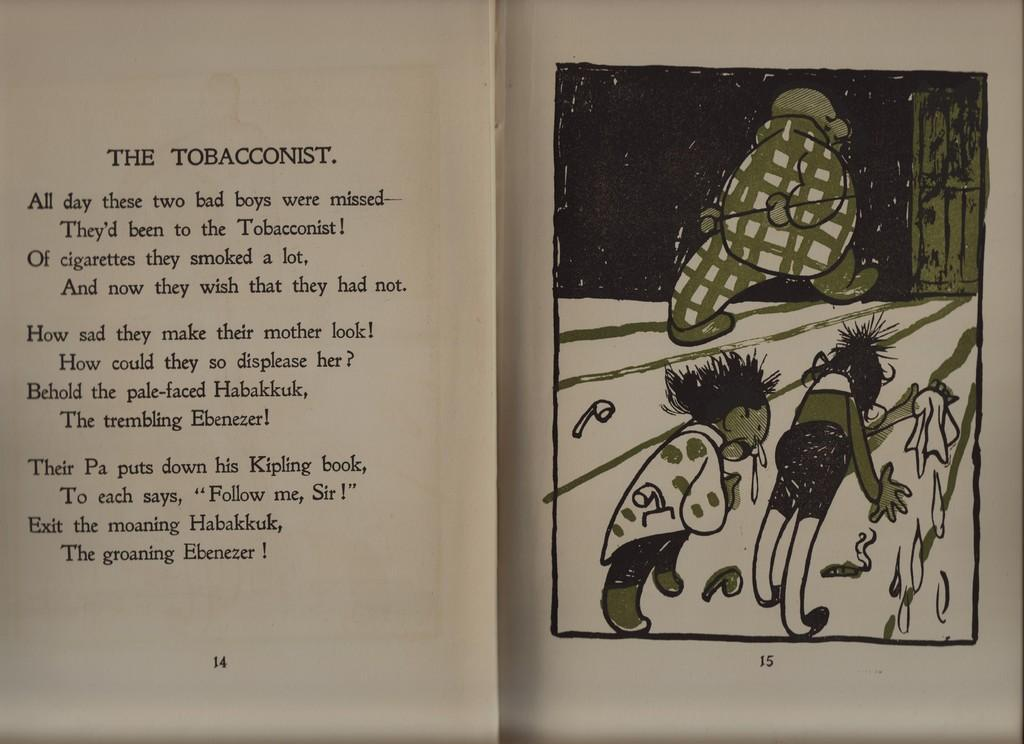<image>
Write a terse but informative summary of the picture. A book is open to page 14, the story being called The Tobacconist 